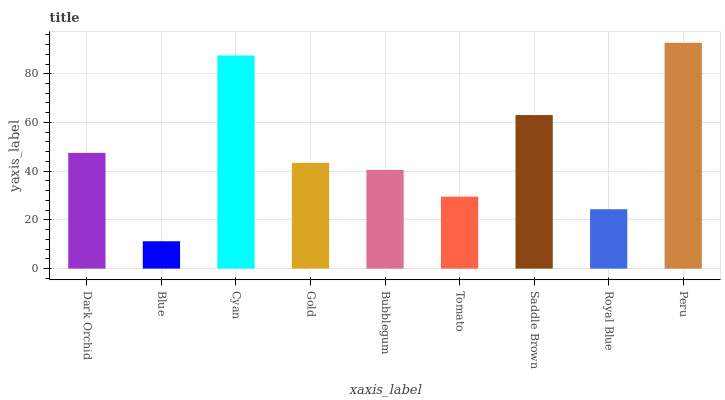Is Blue the minimum?
Answer yes or no. Yes. Is Peru the maximum?
Answer yes or no. Yes. Is Cyan the minimum?
Answer yes or no. No. Is Cyan the maximum?
Answer yes or no. No. Is Cyan greater than Blue?
Answer yes or no. Yes. Is Blue less than Cyan?
Answer yes or no. Yes. Is Blue greater than Cyan?
Answer yes or no. No. Is Cyan less than Blue?
Answer yes or no. No. Is Gold the high median?
Answer yes or no. Yes. Is Gold the low median?
Answer yes or no. Yes. Is Tomato the high median?
Answer yes or no. No. Is Saddle Brown the low median?
Answer yes or no. No. 